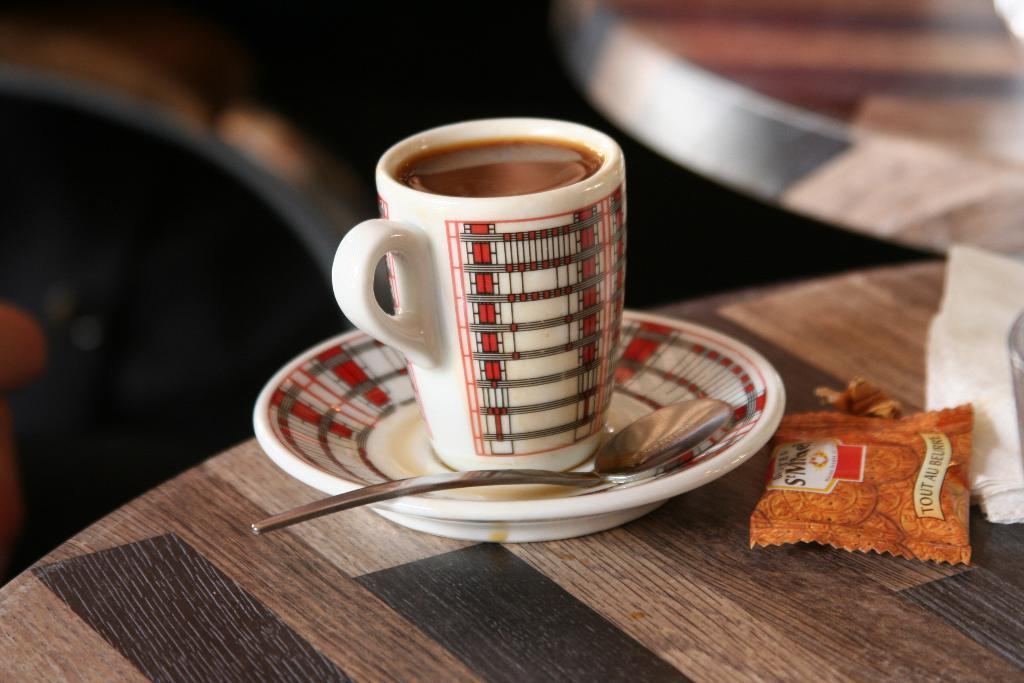What is in the cup that is visible in the image? There is a cup with coffee in the image. What is supporting the cup in the image? There is a saucer below the cup. What utensil is placed beside the cup? There is a spoon beside the cup. What can be seen in the right corner of the image? There are other objects in the right corner of the image. What actor is performing in the image? There is no actor or performance present in the image; it features a cup of coffee with a saucer and spoon. 